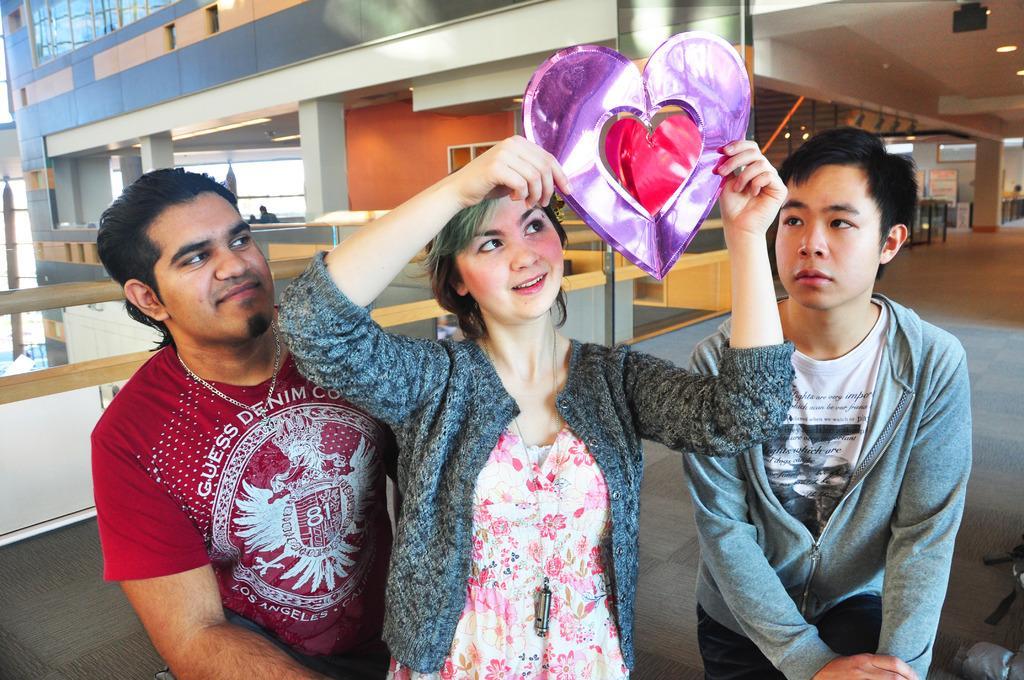How would you summarize this image in a sentence or two? In this image we can see people standing on the floor and one of them is holding a decor in the hands. In the background we can see building, electric lights, boards with text on them, persons and railings. 